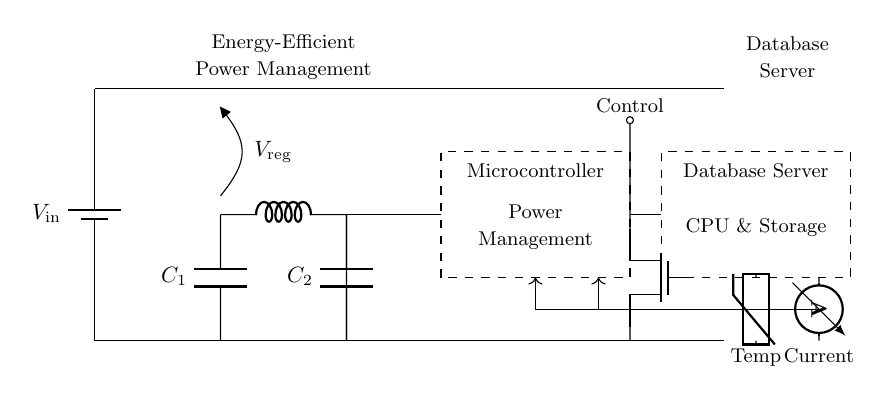What type of voltage regulator is depicted in the circuit? The circuit does not specify the type of voltage regulator, but it is labeled as a generic voltage regulator represented by "V_reg" which indicates a voltage regulation function.
Answer: Voltage Regulator What is the total number of capacitors in this circuit? The circuit shows two capacitors labeled as C_1 and C_2, indicating their presence and count.
Answer: Two What is the role of the thermistor in this circuit? The thermistor is used to measure temperature, as indicated by the label "Temp," providing feedback for the power management system.
Answer: Temperature measurement How does the microcontroller influence the database server? The microcontroller manages the power, ensuring efficient energy use based on the feedback it receives from the sensors monitoring temperature and current, which indirectly affects the operation of the database server.
Answer: Power Management What type of transistor is used to control power to the database server? The circuit includes a power MOSFET, identified by the notation "Tnmos," which serves as a switch for managing the power flow to the database server effectively.
Answer: Power MOSFET How is feedback provided to the microcontroller in this circuit? Feedback is provided through the current and temperature sensors, illustrated by the arrows leading from the sensors to the microcontroller, which informs it about the system's status.
Answer: Via sensors What does the dashed rectangle represent in the circuit diagram? The dashed rectangles indicate the components, specifically the microcontroller and database server, showing that these components have a distinct functional role within the circuit.
Answer: Microcontroller and Database Server 